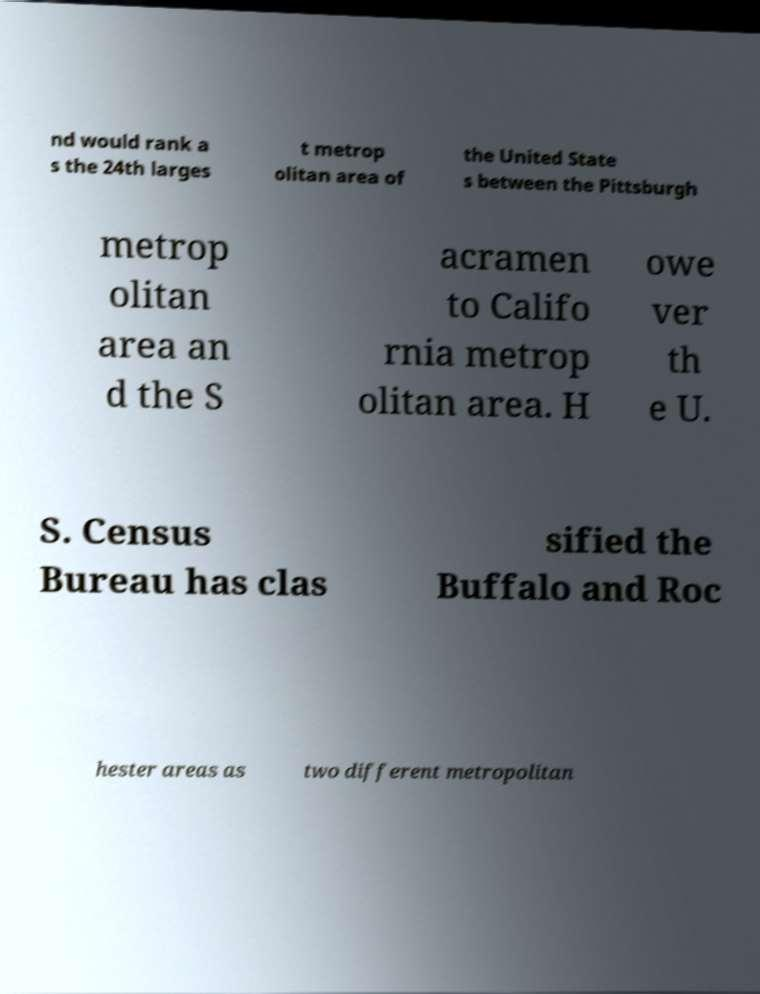Could you extract and type out the text from this image? nd would rank a s the 24th larges t metrop olitan area of the United State s between the Pittsburgh metrop olitan area an d the S acramen to Califo rnia metrop olitan area. H owe ver th e U. S. Census Bureau has clas sified the Buffalo and Roc hester areas as two different metropolitan 